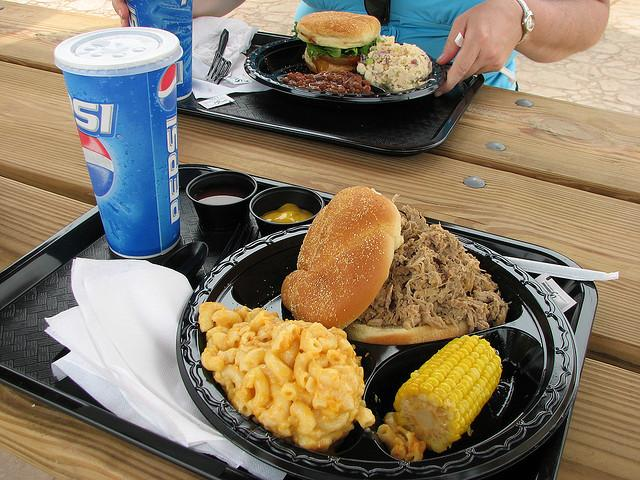Which item on the plate is highest in carbs if the person ate all of it? Please explain your reasoning. macaroni. This is made from flour 